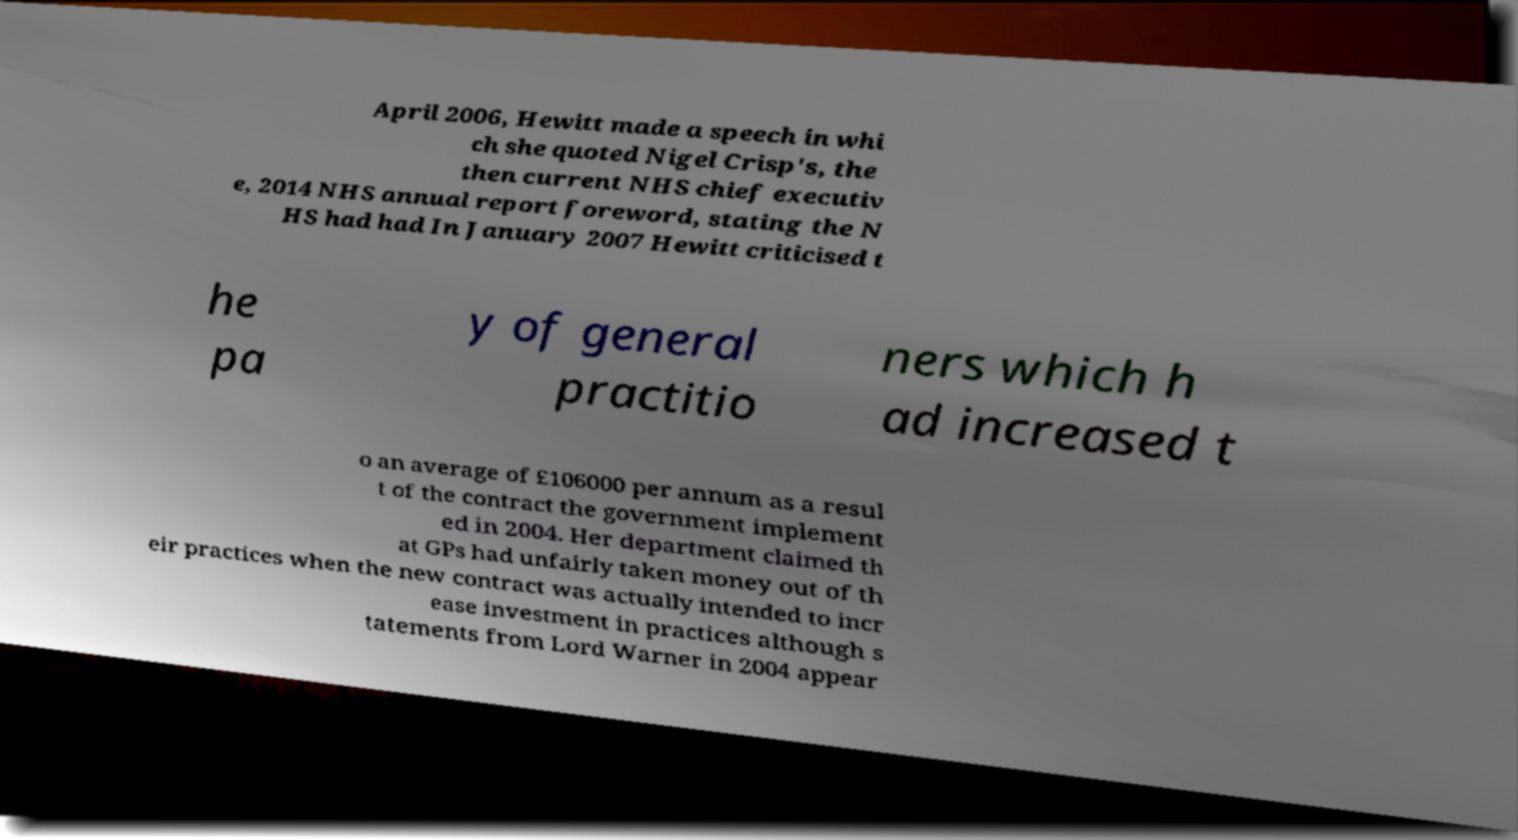Please read and relay the text visible in this image. What does it say? April 2006, Hewitt made a speech in whi ch she quoted Nigel Crisp's, the then current NHS chief executiv e, 2014 NHS annual report foreword, stating the N HS had had In January 2007 Hewitt criticised t he pa y of general practitio ners which h ad increased t o an average of £106000 per annum as a resul t of the contract the government implement ed in 2004. Her department claimed th at GPs had unfairly taken money out of th eir practices when the new contract was actually intended to incr ease investment in practices although s tatements from Lord Warner in 2004 appear 